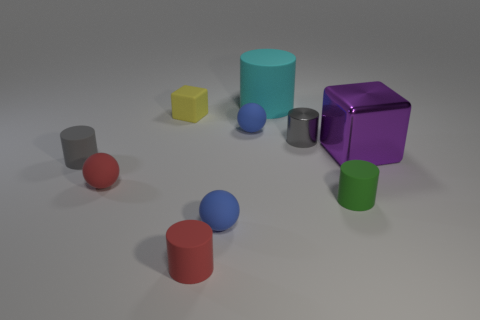There is a purple thing that is the same shape as the yellow matte object; what is it made of?
Your answer should be compact. Metal. There is a small cylinder that is behind the tiny green thing and right of the large rubber object; what is its color?
Your answer should be very brief. Gray. Is there a red rubber ball that is in front of the red matte object behind the tiny blue matte thing that is in front of the small gray metallic cylinder?
Offer a terse response. No. Is the small cube made of the same material as the gray cylinder that is behind the shiny cube?
Your response must be concise. No. What number of objects are rubber cylinders in front of the big cube or small blue matte objects that are behind the purple block?
Ensure brevity in your answer.  4. What is the shape of the small matte thing that is both on the left side of the tiny cube and on the right side of the tiny gray rubber thing?
Offer a terse response. Sphere. There is a matte ball in front of the small green cylinder; what number of large cyan cylinders are to the left of it?
Your answer should be very brief. 0. Is there any other thing that is made of the same material as the tiny yellow object?
Offer a very short reply. Yes. What number of things are either gray cylinders that are on the right side of the cyan rubber object or cyan matte cylinders?
Give a very brief answer. 2. There is a gray cylinder that is behind the small gray rubber cylinder; what is its size?
Make the answer very short. Small. 